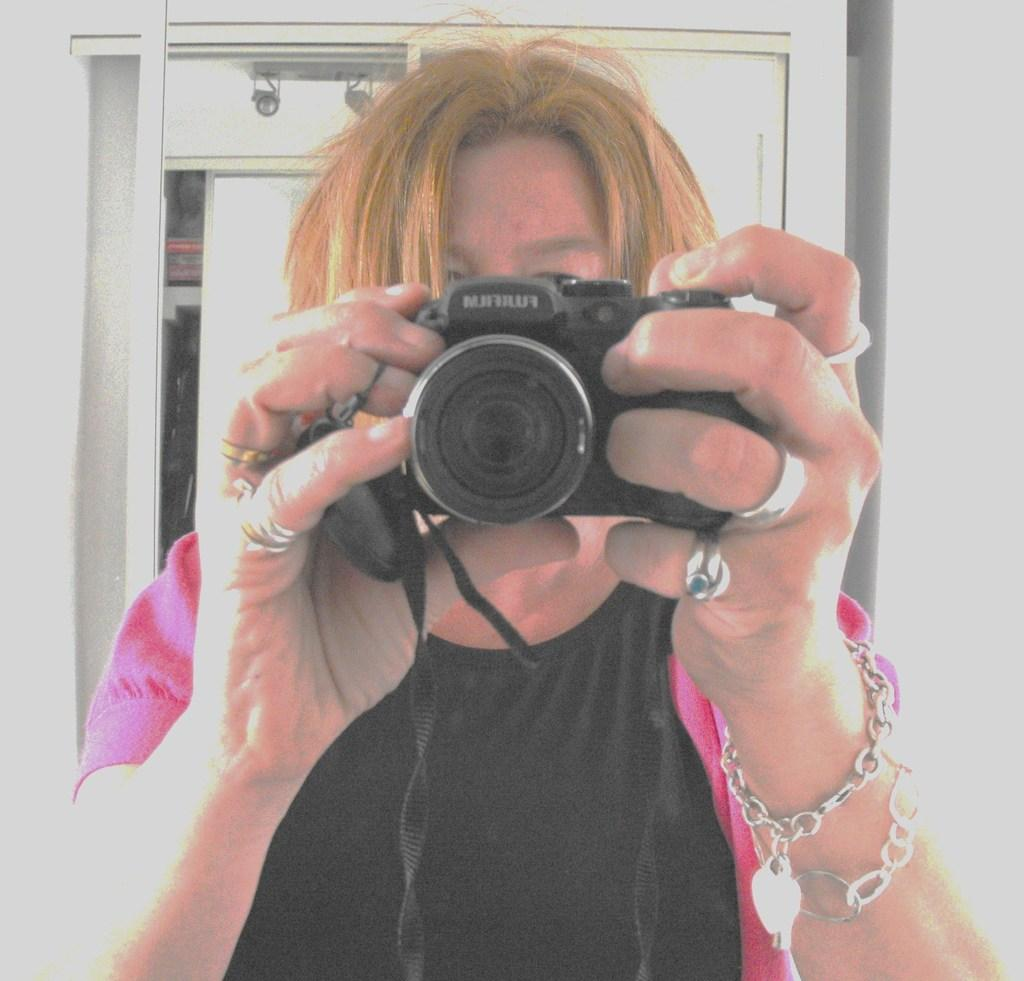Who is the main subject in the image? There is a woman in the image. What is the woman holding in the image? The woman is holding a camera. What can be seen in the background of the image? There is a cupboard and a wall in the background of the image. What material is the cupboard made of? The cupboard is made of wood. What type of line does the carpenter use to build the cupboard in the image? There is no carpenter present in the image, nor is there any indication of the construction process of the cupboard. 